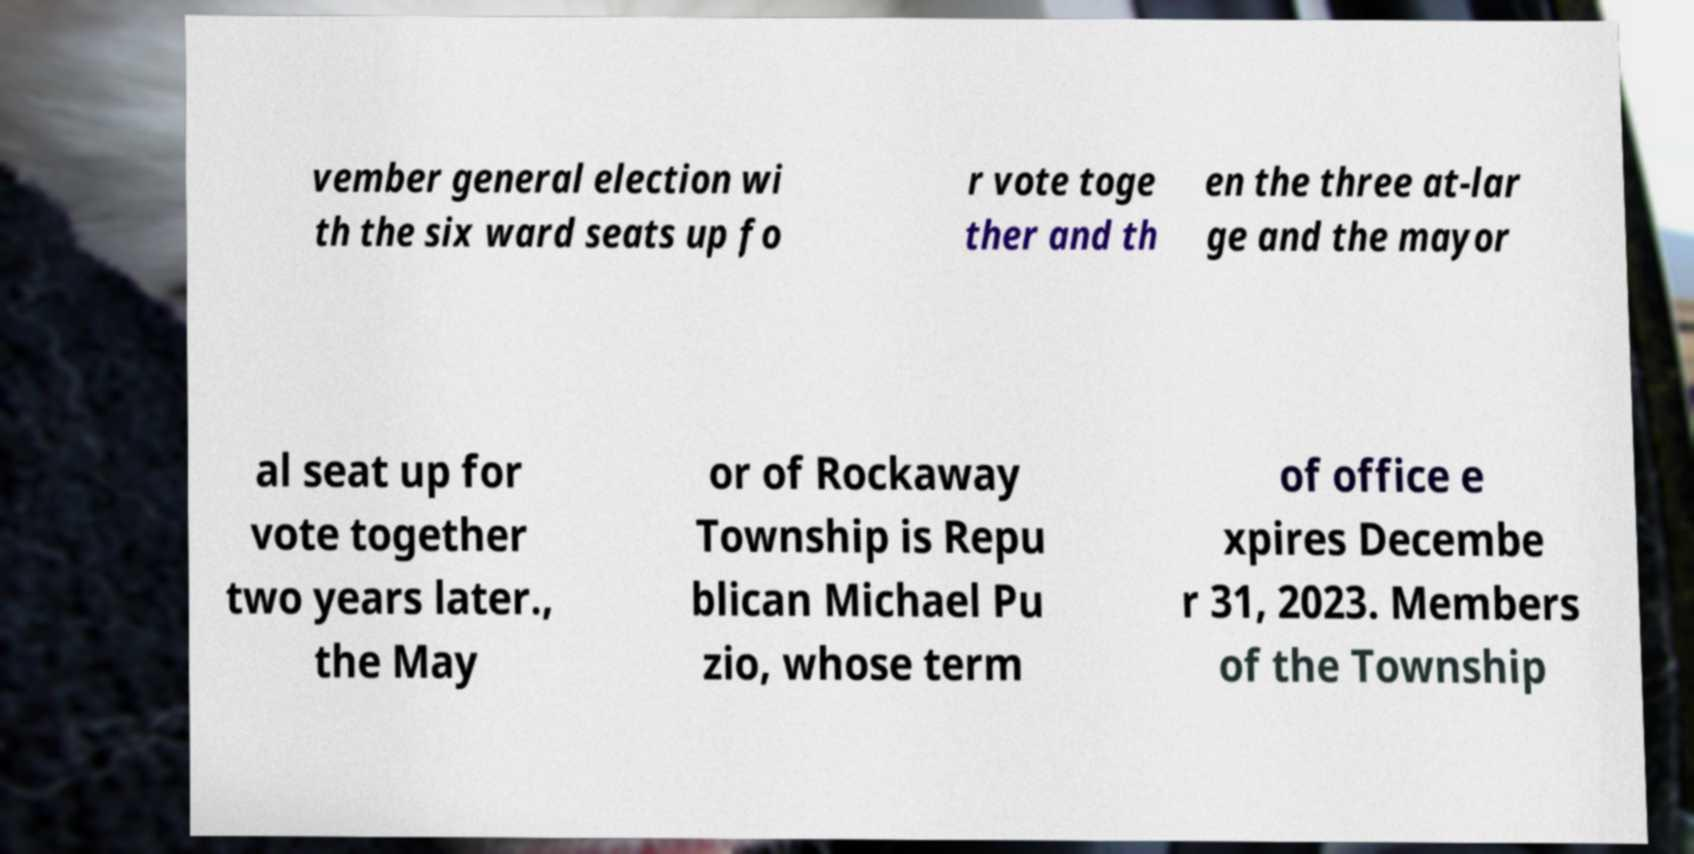Can you accurately transcribe the text from the provided image for me? vember general election wi th the six ward seats up fo r vote toge ther and th en the three at-lar ge and the mayor al seat up for vote together two years later., the May or of Rockaway Township is Repu blican Michael Pu zio, whose term of office e xpires Decembe r 31, 2023. Members of the Township 